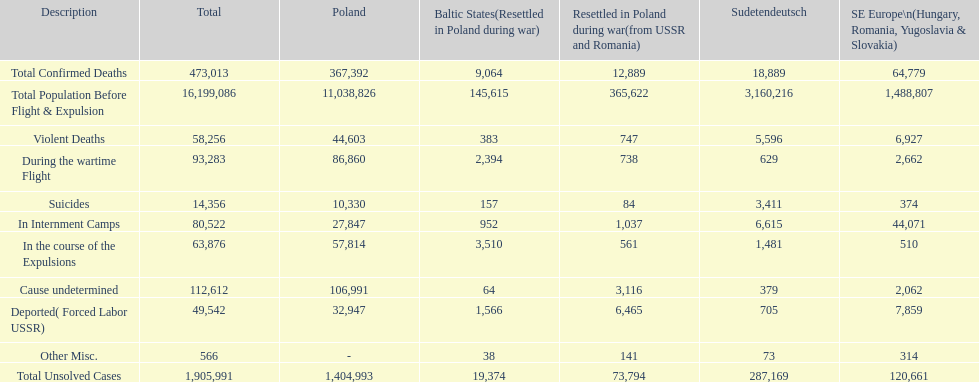Were there more cause undetermined or miscellaneous deaths in the baltic states? Cause undetermined. 